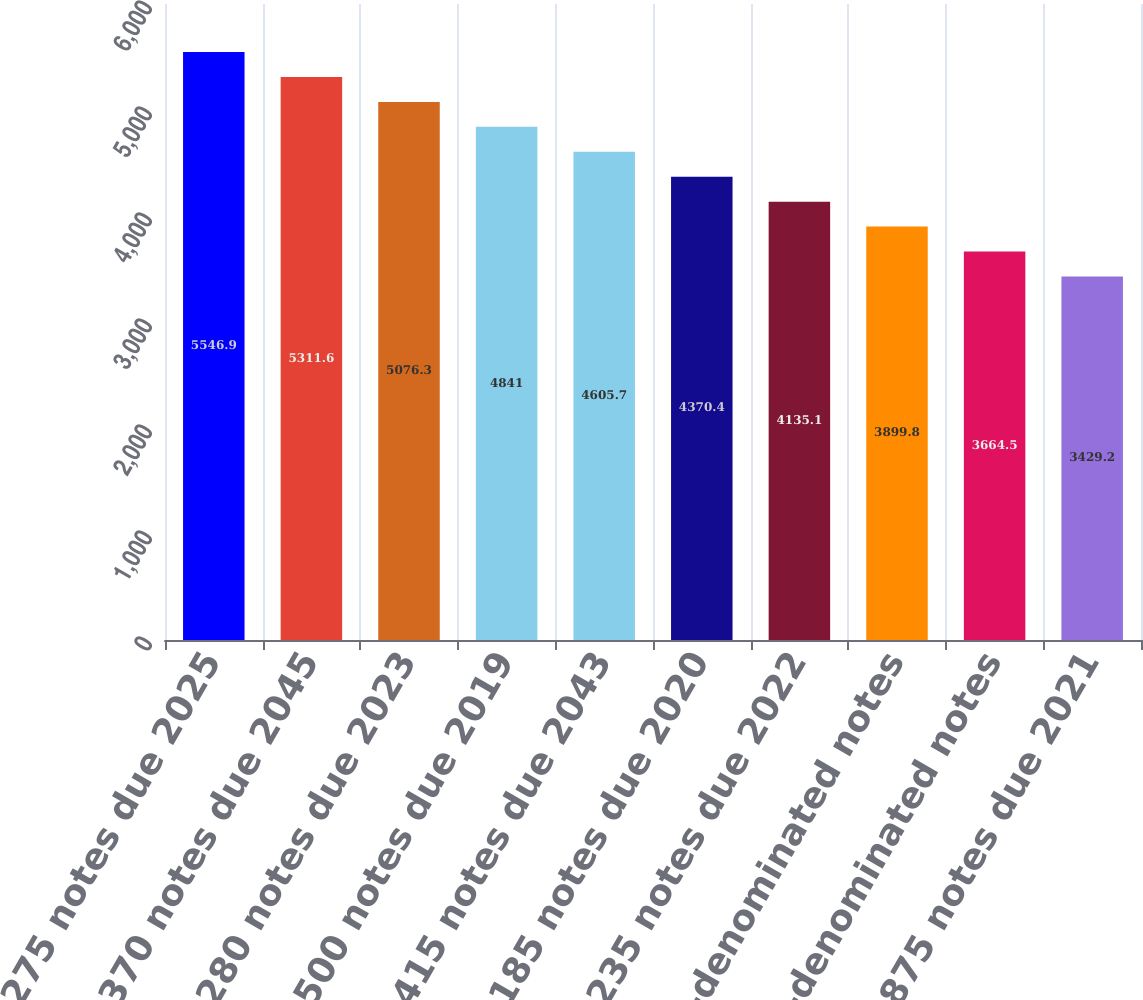Convert chart to OTSL. <chart><loc_0><loc_0><loc_500><loc_500><bar_chart><fcel>275 notes due 2025<fcel>370 notes due 2045<fcel>280 notes due 2023<fcel>500 notes due 2019<fcel>415 notes due 2043<fcel>185 notes due 2020<fcel>235 notes due 2022<fcel>1125 euro-denominated notes<fcel>1875 euro-denominated notes<fcel>3875 notes due 2021<nl><fcel>5546.9<fcel>5311.6<fcel>5076.3<fcel>4841<fcel>4605.7<fcel>4370.4<fcel>4135.1<fcel>3899.8<fcel>3664.5<fcel>3429.2<nl></chart> 